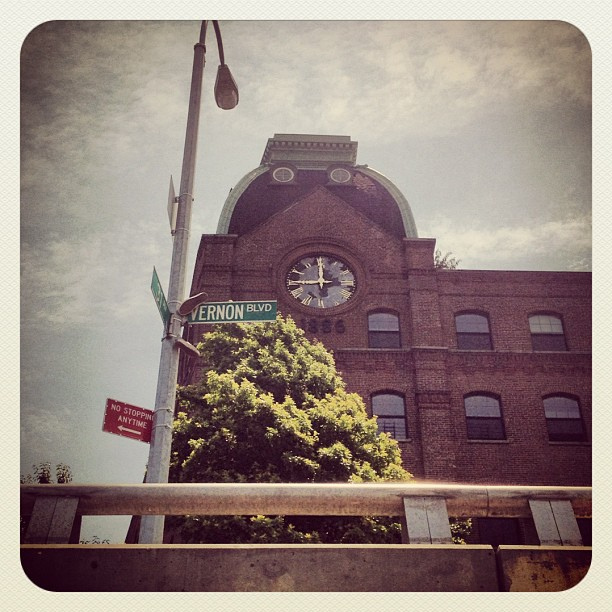What kind of material is the building made out?
Answer the question using a single word or phrase. The building appears to be constructed of red brick, which is commonly used for its durability and the charming aesthetic it provides. 